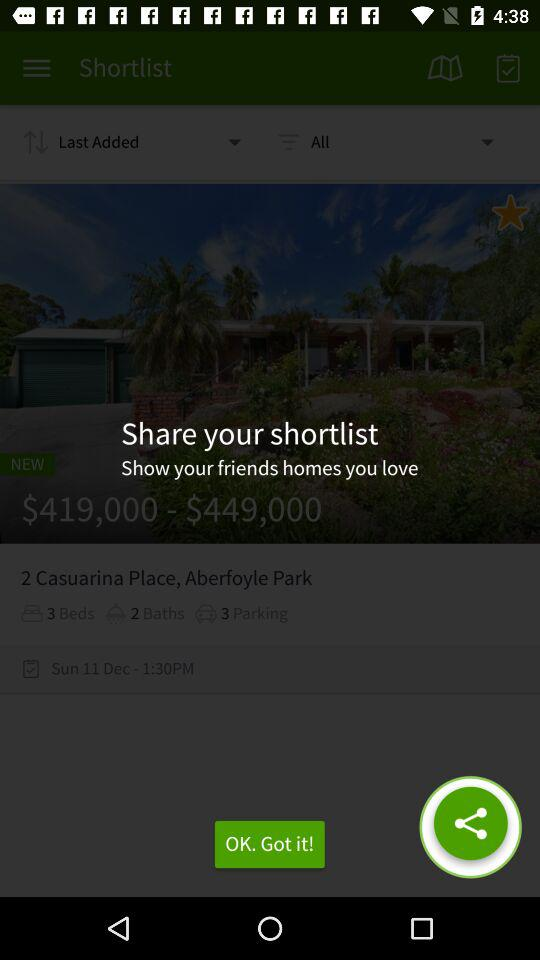How many beds are available in the property?
Answer the question using a single word or phrase. 3 